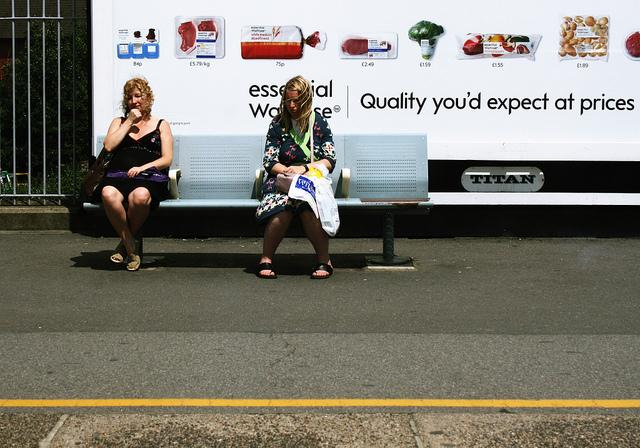What is the large object trying to get you to do?

Choices:
A) drive safe
B) buy goods
C) watch tv
D) join army buy goods 